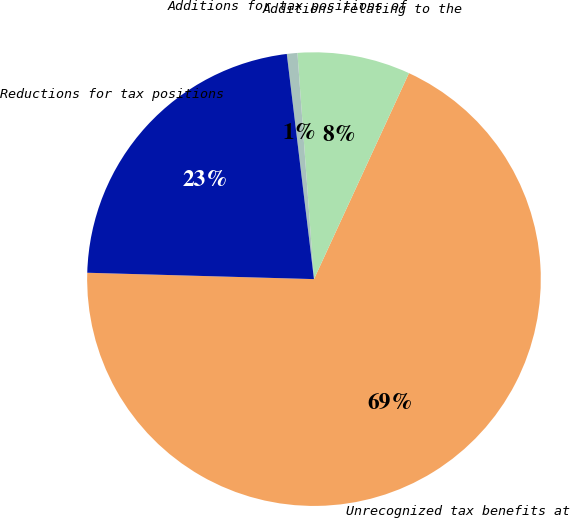<chart> <loc_0><loc_0><loc_500><loc_500><pie_chart><fcel>Unrecognized tax benefits at<fcel>Additions relating to the<fcel>Additions for tax positions of<fcel>Reductions for tax positions<nl><fcel>68.57%<fcel>8.04%<fcel>0.75%<fcel>22.64%<nl></chart> 